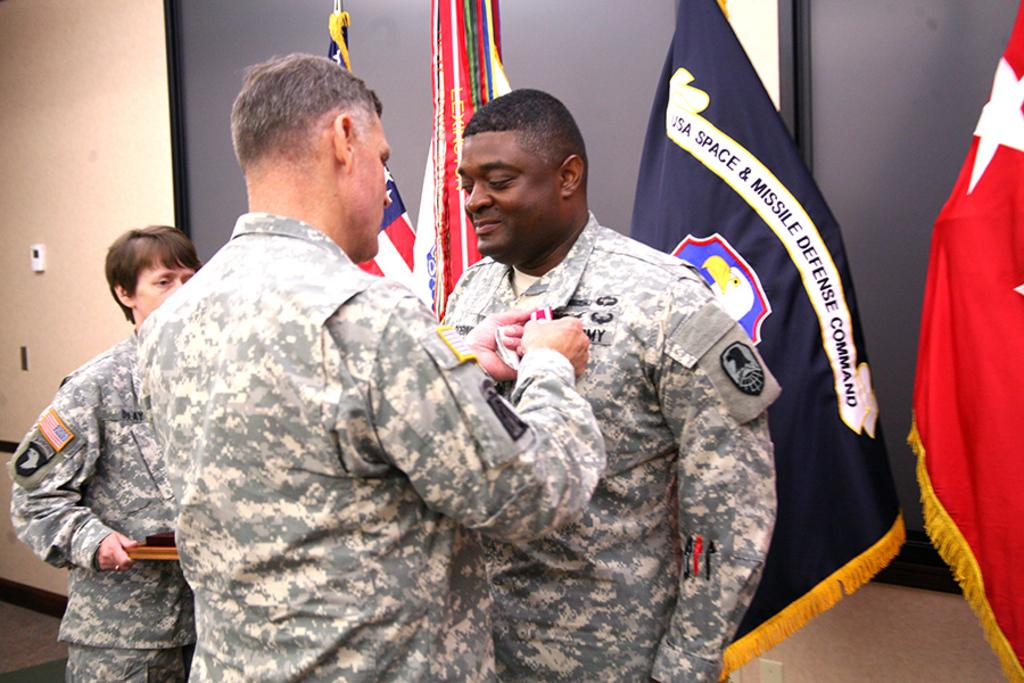<image>
Summarize the visual content of the image. A man in the US Army is attaching a pin to another soldiers uniform as they stand in front of a USA Space & Missile Defense Command flag. 